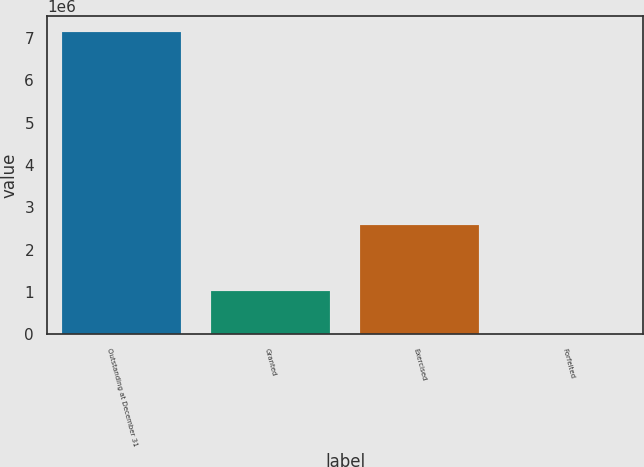Convert chart to OTSL. <chart><loc_0><loc_0><loc_500><loc_500><bar_chart><fcel>Outstanding at December 31<fcel>Granted<fcel>Exercised<fcel>Forfeited<nl><fcel>7.15218e+06<fcel>1.0167e+06<fcel>2.57009e+06<fcel>13000<nl></chart> 